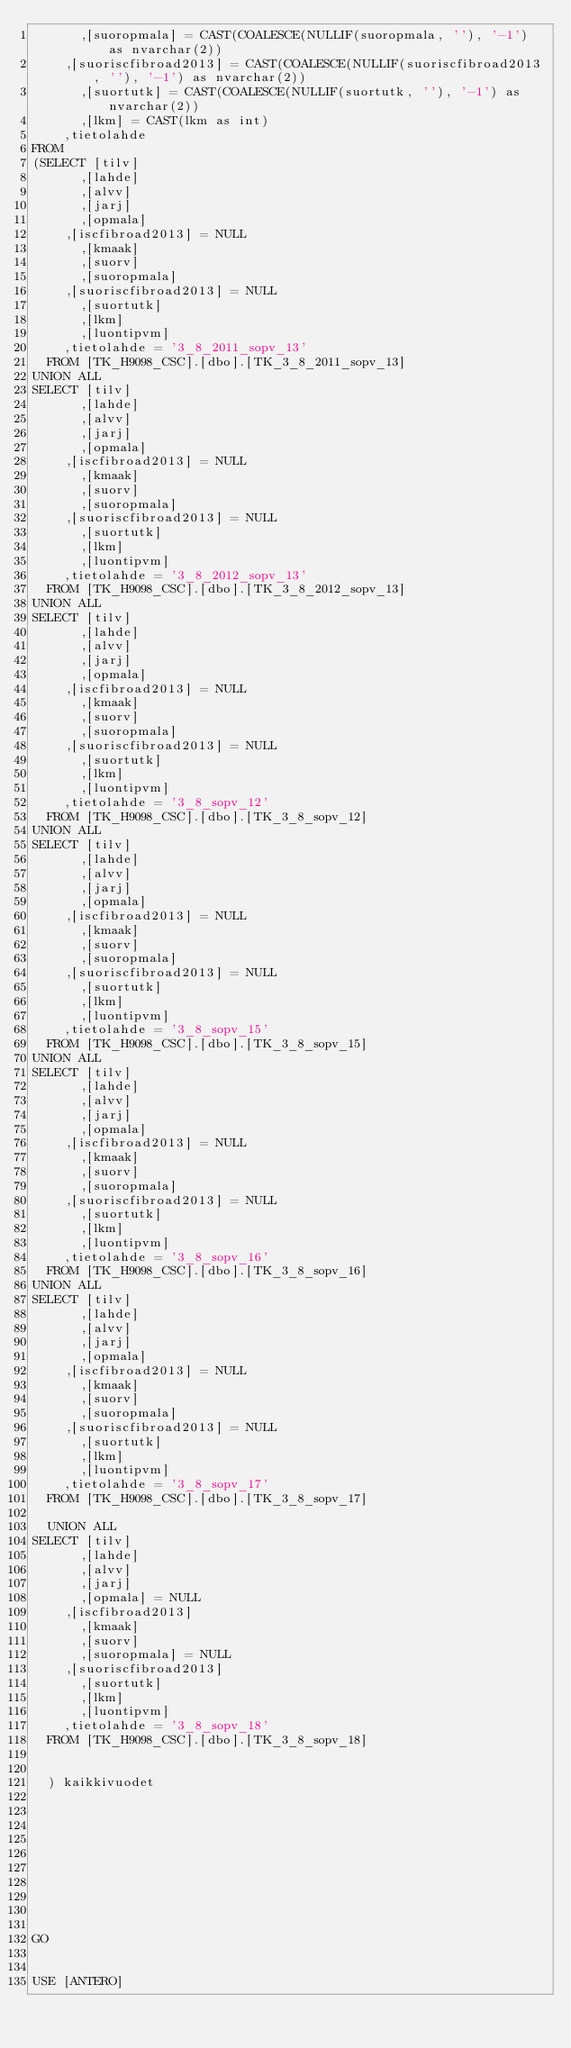Convert code to text. <code><loc_0><loc_0><loc_500><loc_500><_SQL_>      ,[suoropmala] = CAST(COALESCE(NULLIF(suoropmala, ''), '-1') as nvarchar(2))
	  ,[suoriscfibroad2013] = CAST(COALESCE(NULLIF(suoriscfibroad2013, ''), '-1') as nvarchar(2))
      ,[suortutk] = CAST(COALESCE(NULLIF(suortutk, ''), '-1') as nvarchar(2))
      ,[lkm] = CAST(lkm as int)
	  ,tietolahde
FROM
(SELECT [tilv]
      ,[lahde]
      ,[alvv]
      ,[jarj]
      ,[opmala]
	  ,[iscfibroad2013] = NULL
      ,[kmaak]
      ,[suorv]
      ,[suoropmala]
	  ,[suoriscfibroad2013] = NULL
      ,[suortutk]
      ,[lkm]
      ,[luontipvm]
	  ,tietolahde = '3_8_2011_sopv_13'
  FROM [TK_H9098_CSC].[dbo].[TK_3_8_2011_sopv_13]
UNION ALL
SELECT [tilv]
      ,[lahde]
      ,[alvv]
      ,[jarj]
      ,[opmala]
	  ,[iscfibroad2013] = NULL
      ,[kmaak]
      ,[suorv]
      ,[suoropmala]
	  ,[suoriscfibroad2013] = NULL
      ,[suortutk]
      ,[lkm]
      ,[luontipvm]
	  ,tietolahde = '3_8_2012_sopv_13'
  FROM [TK_H9098_CSC].[dbo].[TK_3_8_2012_sopv_13]
UNION ALL
SELECT [tilv]
      ,[lahde]
      ,[alvv]
      ,[jarj]
      ,[opmala]
	  ,[iscfibroad2013] = NULL
      ,[kmaak]
      ,[suorv]
      ,[suoropmala]
	  ,[suoriscfibroad2013] = NULL
      ,[suortutk]
      ,[lkm]
      ,[luontipvm]
	  ,tietolahde = '3_8_sopv_12'
  FROM [TK_H9098_CSC].[dbo].[TK_3_8_sopv_12]
UNION ALL
SELECT [tilv]
      ,[lahde]
      ,[alvv]
      ,[jarj]
      ,[opmala]
	  ,[iscfibroad2013] = NULL
      ,[kmaak]
      ,[suorv]
      ,[suoropmala]
	  ,[suoriscfibroad2013] = NULL
      ,[suortutk]
      ,[lkm]
      ,[luontipvm]
	  ,tietolahde = '3_8_sopv_15'
  FROM [TK_H9098_CSC].[dbo].[TK_3_8_sopv_15]
UNION ALL
SELECT [tilv]
      ,[lahde]
      ,[alvv]
      ,[jarj]
      ,[opmala]
	  ,[iscfibroad2013] = NULL
      ,[kmaak]
      ,[suorv]
      ,[suoropmala]
	  ,[suoriscfibroad2013] = NULL
      ,[suortutk]
      ,[lkm]
      ,[luontipvm]
	  ,tietolahde = '3_8_sopv_16'
  FROM [TK_H9098_CSC].[dbo].[TK_3_8_sopv_16]
UNION ALL
SELECT [tilv]
      ,[lahde]
      ,[alvv]
      ,[jarj]
      ,[opmala]
	  ,[iscfibroad2013] = NULL
      ,[kmaak]
      ,[suorv]
      ,[suoropmala]
	  ,[suoriscfibroad2013] = NULL
      ,[suortutk]
      ,[lkm]
      ,[luontipvm]
	  ,tietolahde = '3_8_sopv_17'
  FROM [TK_H9098_CSC].[dbo].[TK_3_8_sopv_17]

  UNION ALL
SELECT [tilv]
      ,[lahde]
      ,[alvv]
      ,[jarj]
      ,[opmala] = NULL
	  ,[iscfibroad2013]
      ,[kmaak]
      ,[suorv]
      ,[suoropmala] = NULL
	  ,[suoriscfibroad2013]
      ,[suortutk]
      ,[lkm]
      ,[luontipvm]
	  ,tietolahde = '3_8_sopv_18'
  FROM [TK_H9098_CSC].[dbo].[TK_3_8_sopv_18]
  
  
  ) kaikkivuodet










GO


USE [ANTERO]</code> 